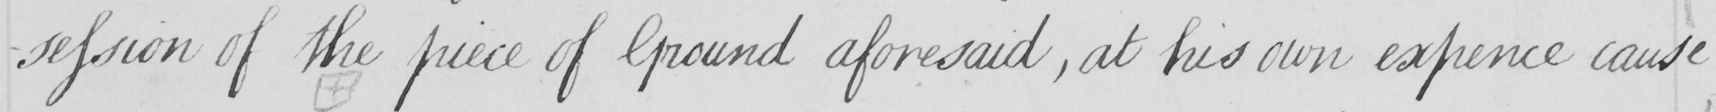What is written in this line of handwriting? -session of the piece of Ground aforesaid , at his own expence cause 